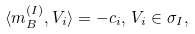<formula> <loc_0><loc_0><loc_500><loc_500>\langle m _ { B } ^ { ( I ) } , V _ { i } \rangle = - c _ { i } , \, V _ { i } \in \sigma _ { I } ,</formula> 